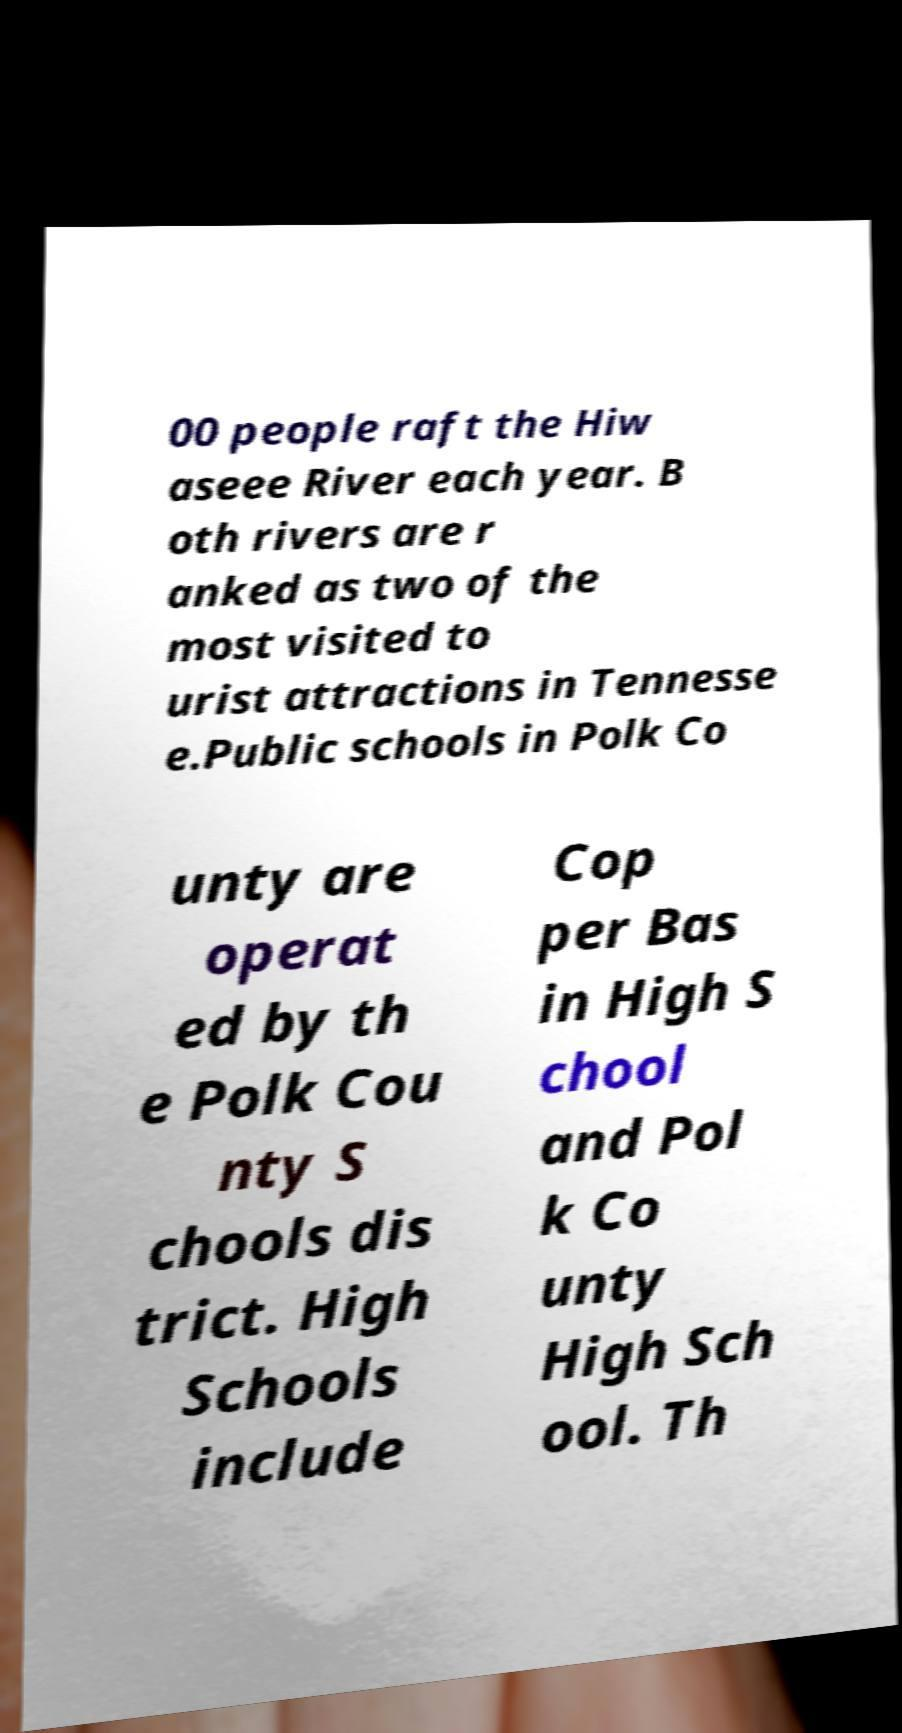Can you accurately transcribe the text from the provided image for me? 00 people raft the Hiw aseee River each year. B oth rivers are r anked as two of the most visited to urist attractions in Tennesse e.Public schools in Polk Co unty are operat ed by th e Polk Cou nty S chools dis trict. High Schools include Cop per Bas in High S chool and Pol k Co unty High Sch ool. Th 